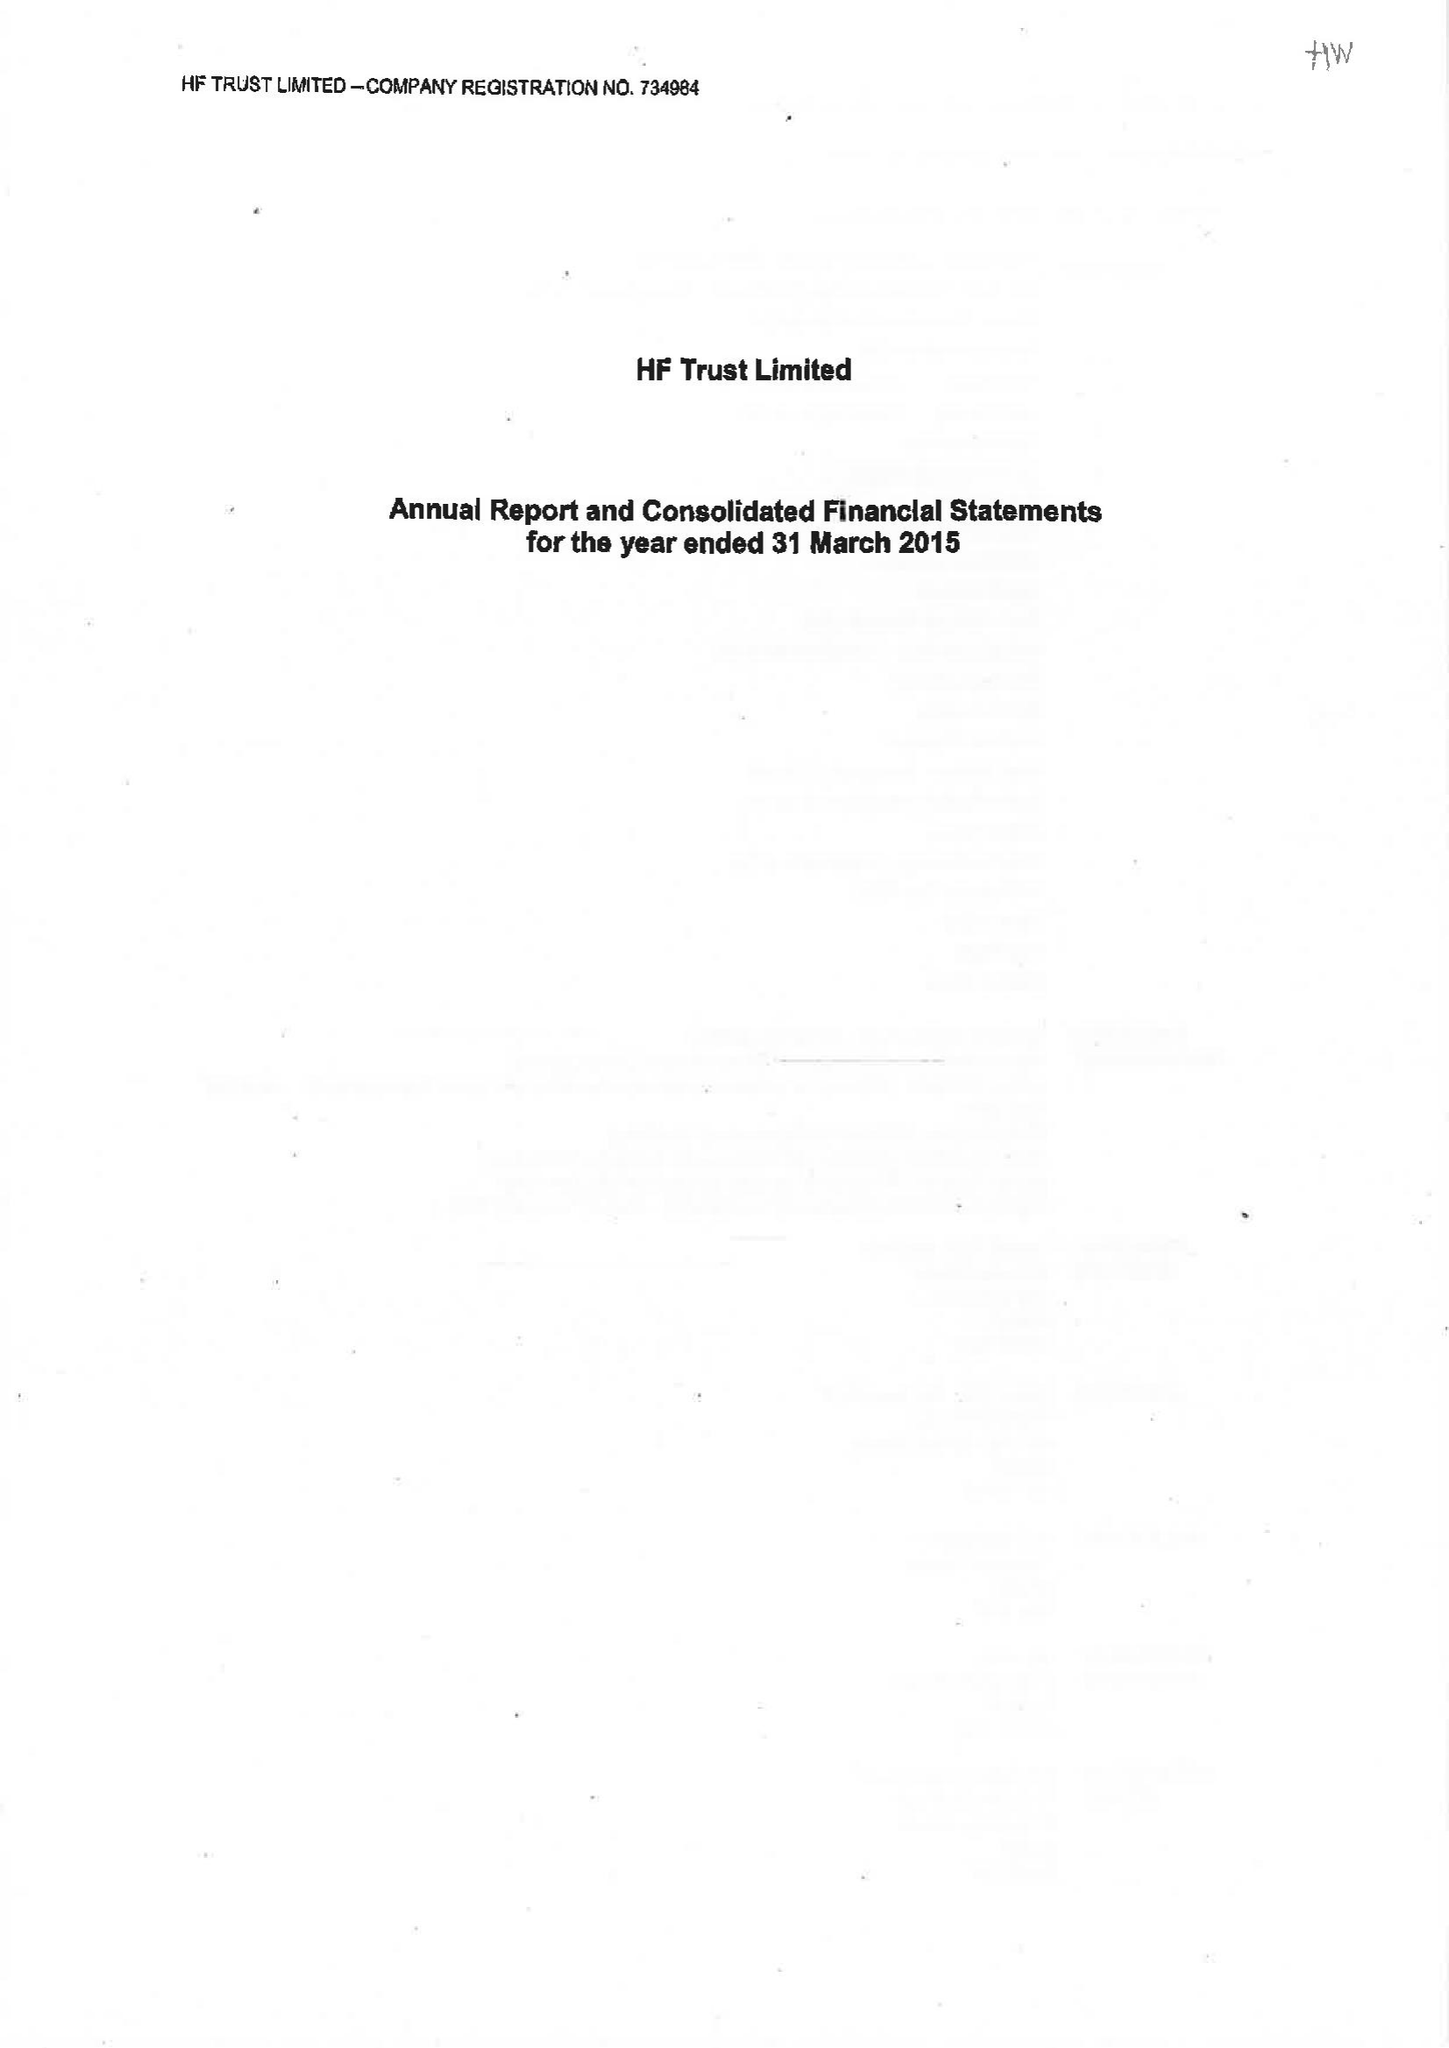What is the value for the income_annually_in_british_pounds?
Answer the question using a single word or phrase. 73556000.00 